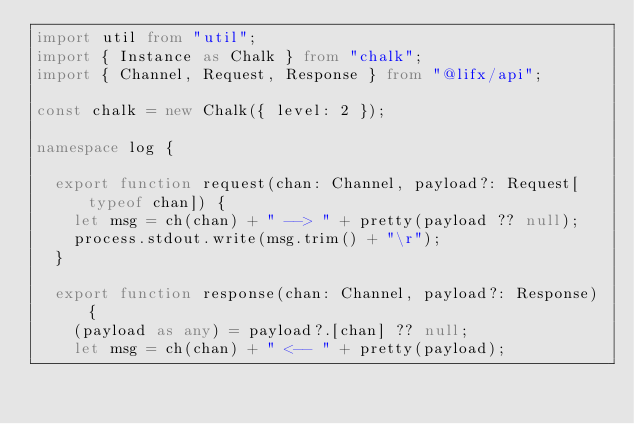Convert code to text. <code><loc_0><loc_0><loc_500><loc_500><_TypeScript_>import util from "util";
import { Instance as Chalk } from "chalk";
import { Channel, Request, Response } from "@lifx/api";

const chalk = new Chalk({ level: 2 });

namespace log {

	export function request(chan: Channel, payload?: Request[typeof chan]) {
		let msg = ch(chan) + " --> " + pretty(payload ?? null);
		process.stdout.write(msg.trim() + "\r");
	}

	export function response(chan: Channel, payload?: Response) {
		(payload as any) = payload?.[chan] ?? null;
		let msg = ch(chan) + " <-- " + pretty(payload);</code> 